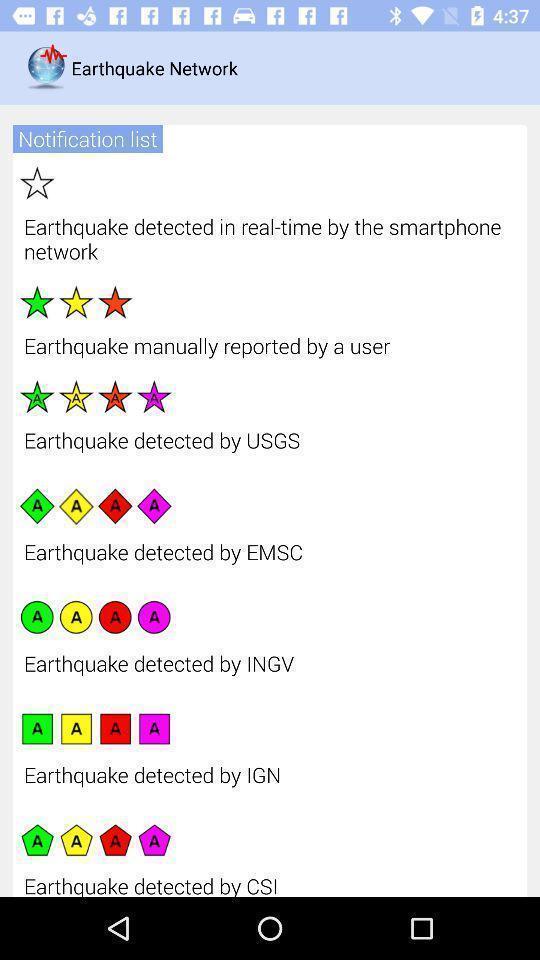Describe the visual elements of this screenshot. Page displaying information list by different centers. 